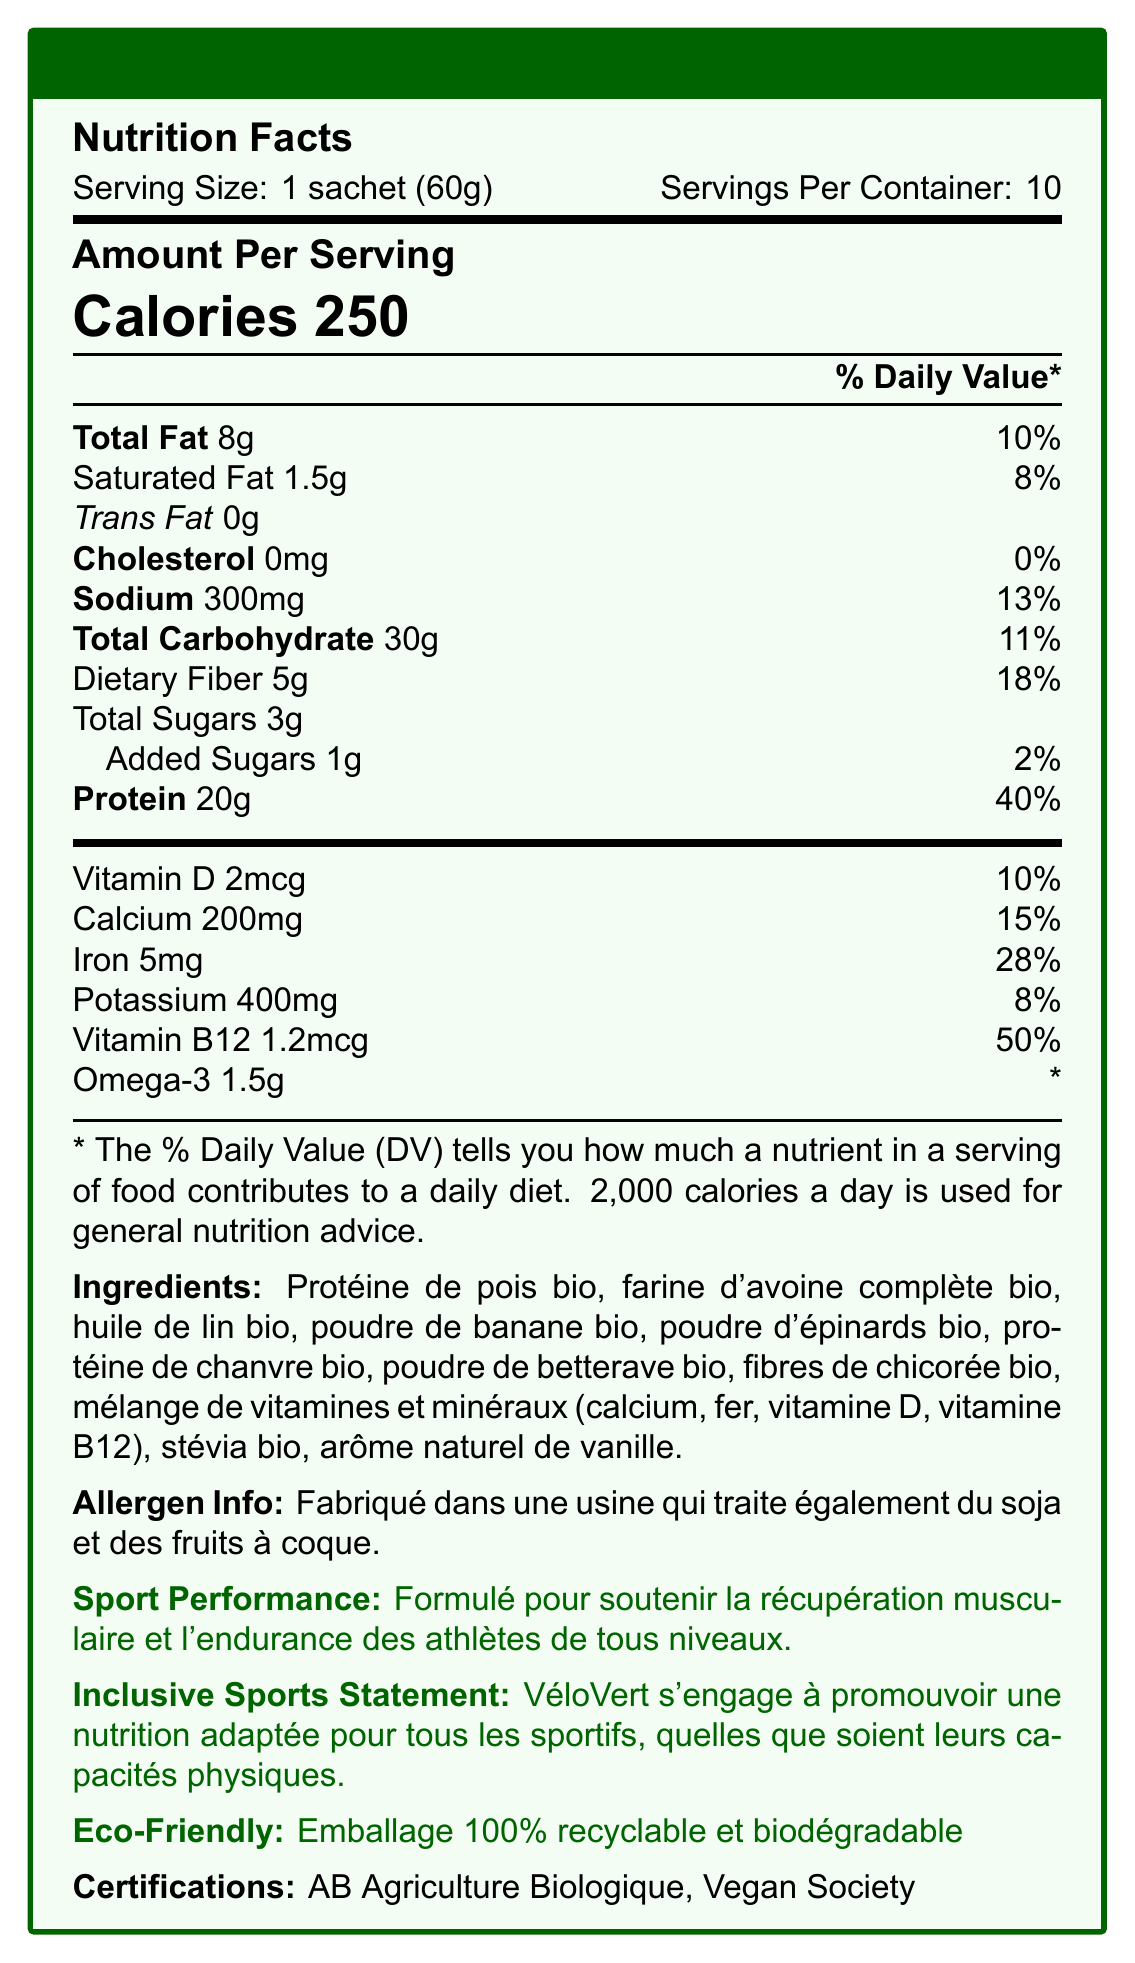what is the serving size for VéloVert Repas Complet Végétal? The serving size is clearly mentioned at the beginning of the document as "Serving Size: 1 sachet (60g)".
Answer: 1 sachet (60g) what is the total fat content per serving? The total fat content per serving is listed under "Amount Per Serving" as "Total Fat 8g".
Answer: 8g how much protein is in one serving? The protein content for one serving is listed under "Amount Per Serving" as "Protein 20g".
Answer: 20g which vitamin has the highest daily value percentage per serving? The daily value percentages are listed under each nutrient. Vitamin B12 has the highest daily value percentage at 50%.
Answer: Vitamin B12 what is the sodium content per serving? The sodium content per serving is listed under "Amount Per Serving" as "Sodium 300mg".
Answer: 300mg how many servings are there in one container? A. 5 B. 10 C. 15 D. 20 The number of servings per container is indicated at the beginning of the document as "Servings Per Container: 10".
Answer: B. 10 what is the main ingredient of the VéloVert Repas Complet Végétal shake? A. Protéine de pois bio B. Huile de lin bio C. Fibre de chicorée bio D. Poudre d'épinards bio The main ingredient is listed first in the ingredients list, which is "Protéine de pois bio".
Answer: A. Protéine de pois bio does the product contain any trans fat? The "Amount Per Serving" section lists the trans fat as "0g", indicating that it contains no trans fat.
Answer: No summarize the key features of the VéloVert Repas Complet Végétal nutrition facts. The summary provides an overview of the nutritional content, purpose, environmental benefits, and certifications of the VéloVert Repas Complet Végétal.
Answer: The VéloVert Repas Complet Végétal is a plant-based meal replacement shake that offers balanced macronutrients and supports muscle recovery and endurance. Each 60g sachet provides 250 calories, 8g of fat, 30g of carbohydrates (including 5g of dietary fiber), and 20g of protein. It also supplies various vitamins and minerals, including significant amounts of Vitamin B12. The product is eco-friendly, with packaging that is 100% recyclable and biodegradable, and it holds certifications such as AB Agriculture Biologique and Vegan Society. how much dietary fiber is in one serving? The amount of dietary fiber per serving is noted under "Amount Per Serving" as "Dietary Fiber 5g".
Answer: 5g what are the certifications listed for the product? The certifications are listed at the end of the document under "Certifications".
Answer: AB Agriculture Biologique, Vegan Society is the packaging eco-friendly? The document states that the packaging is "100% recyclable and biodegradable".
Answer: Yes what nutrient contributes the most to daily protein requirements per serving? The document lists the daily value for protein as 40%, which is the highest percentage listed for any nutrient per serving.
Answer: Protein what is the amount of added sugars in one serving? The amount of added sugars per serving is listed under "Total Carbohydrate" as "Added Sugars 1g".
Answer: 1g how many calories does one serving of VéloVert Repas Complet Végétal contain? The calorie content per serving is prominently displayed as "Calories 250".
Answer: 250 does the product contain any animal-based ingredients? Based on the ingredients list and the Vegan Society certification, the product does not contain any animal-based ingredients.
Answer: No where is the product manufactured? The document does not provide specific information on where the product is manufactured.
Answer: Not enough information what is the purpose of the plant-based shake according to the document? The document mentions under "Sport Performance" that the plant-based shake is formulated to support muscle recovery and endurance for athletes of all levels.
Answer: To support muscle recovery and endurance for athletes of all levels what is the daily value percentage of iron per serving? The daily value percentage for iron per serving is listed as 28%.
Answer: 28% can this product be consumed safely by someone with a nut allergy? The allergen information states that the product is manufactured in a facility that processes nuts, so there is a risk of cross-contamination.
Answer: Maybe 